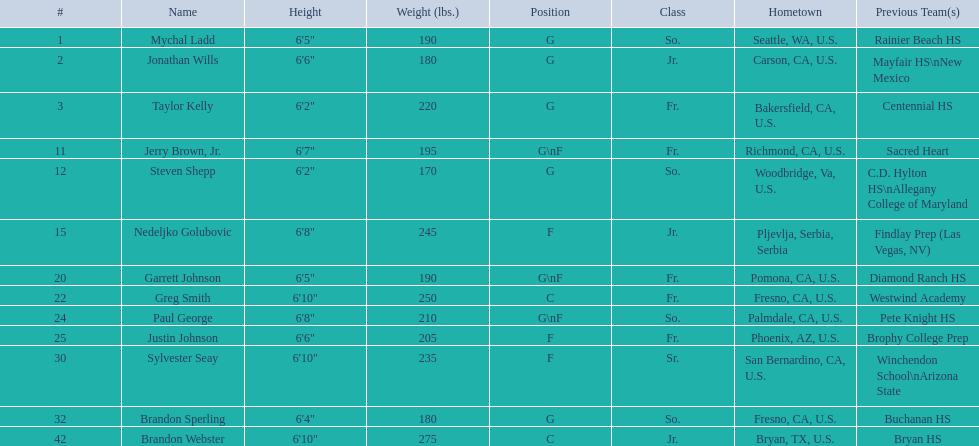Who are all the participants? Mychal Ladd, Jonathan Wills, Taylor Kelly, Jerry Brown, Jr., Steven Shepp, Nedeljko Golubovic, Garrett Johnson, Greg Smith, Paul George, Justin Johnson, Sylvester Seay, Brandon Sperling, Brandon Webster. What is their height? 6'5", 6'6", 6'2", 6'7", 6'2", 6'8", 6'5", 6'10", 6'8", 6'6", 6'10", 6'4", 6'10". Specifically, paul george and greg smith? 6'10", 6'8". And who is the taller one between them? Greg Smith. 